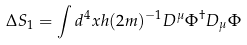<formula> <loc_0><loc_0><loc_500><loc_500>\Delta S _ { 1 } = \int d ^ { 4 } x h ( 2 m ) ^ { - 1 } D ^ { \mu } \Phi ^ { \dagger } D _ { \mu } \Phi</formula> 